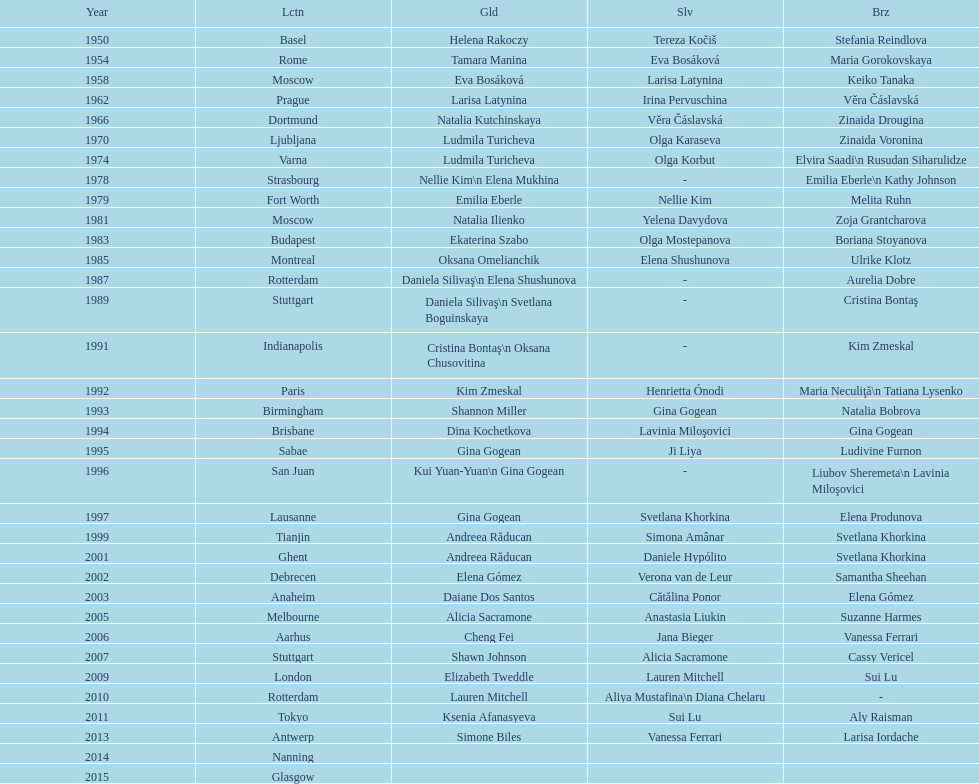As of 2013, what is the total number of floor exercise gold medals won by american women at the world championships? 5. 